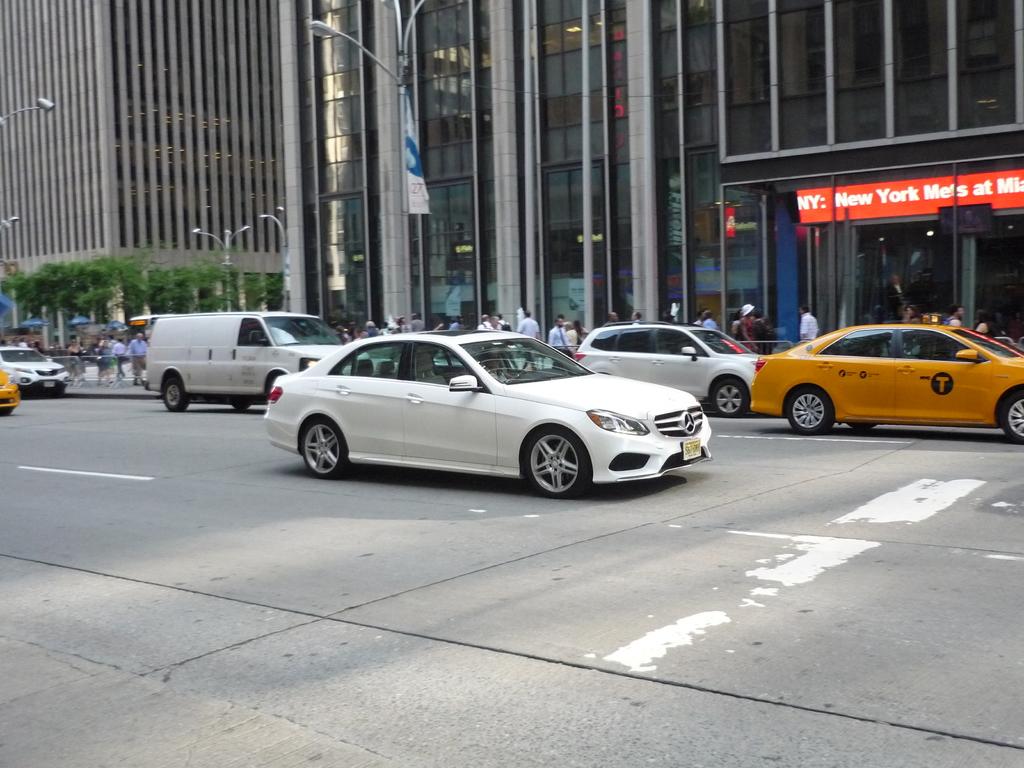What baseball team is listed on the red banner in the background?
Offer a terse response. New york mets. 